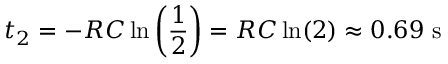Convert formula to latex. <formula><loc_0><loc_0><loc_500><loc_500>t _ { 2 } = - R C \ln \left ( \frac { 1 } { 2 } \right ) = R C \ln ( 2 ) \approx 0 . 6 9 s</formula> 